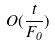<formula> <loc_0><loc_0><loc_500><loc_500>O ( \frac { t } { F _ { 0 } } )</formula> 